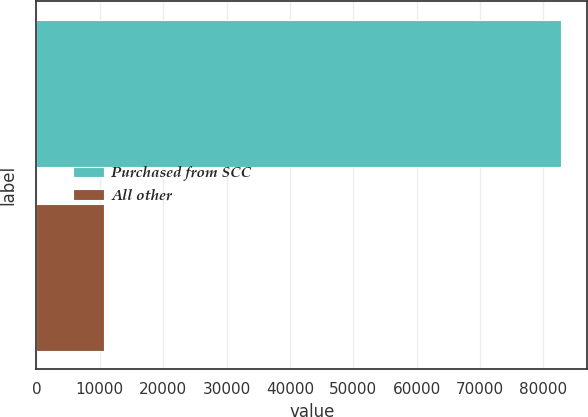Convert chart to OTSL. <chart><loc_0><loc_0><loc_500><loc_500><bar_chart><fcel>Purchased from SCC<fcel>All other<nl><fcel>82793<fcel>10742<nl></chart> 